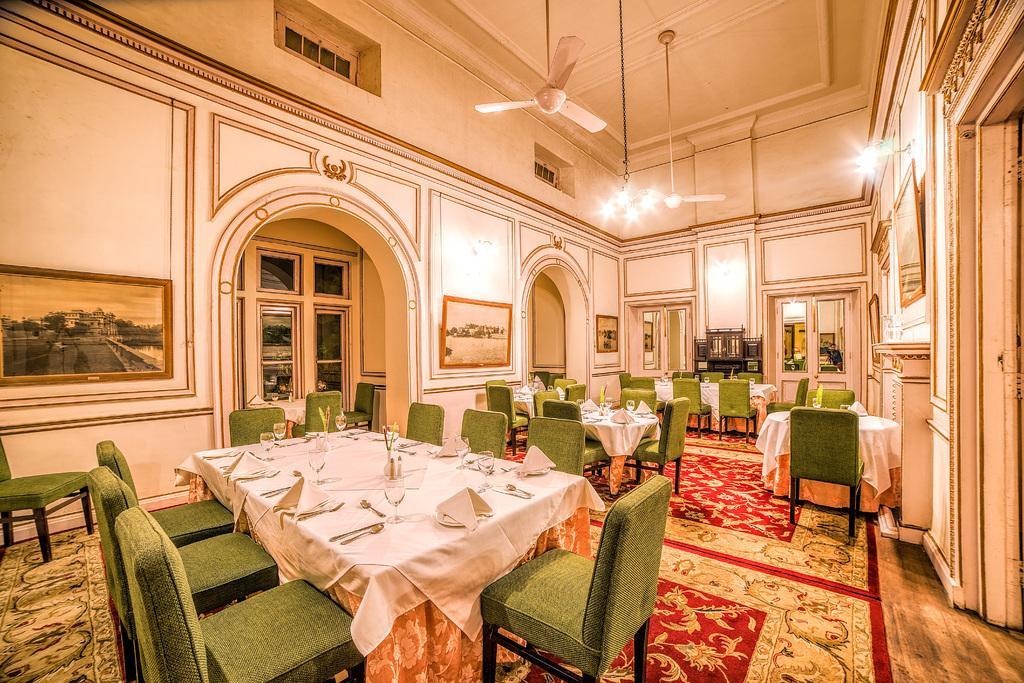Can you describe this image briefly? In this image I can see number of green colour chairs, tables, ceiling fans, lights, frames on these walls and on these tables I can see white colour table cloths, number of spoons, napkins, glasses and few other stuffs. 